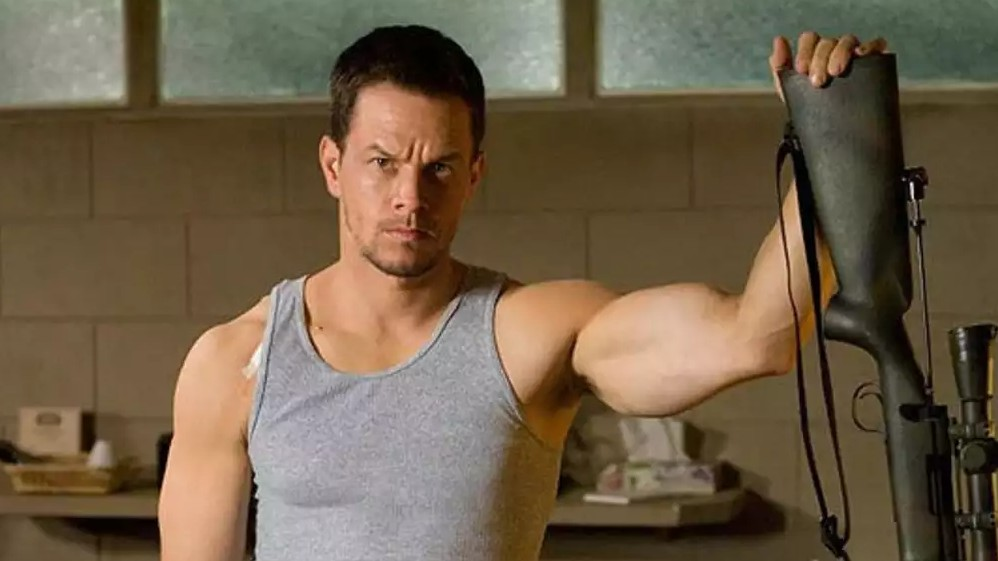What does the expression on the man's face suggest about his situation? The man's serious expression, coupled with his steady gaze, suggests he may be in a situation requiring focus and caution, potentially preparing for a challenging task or facing a significant threat. 